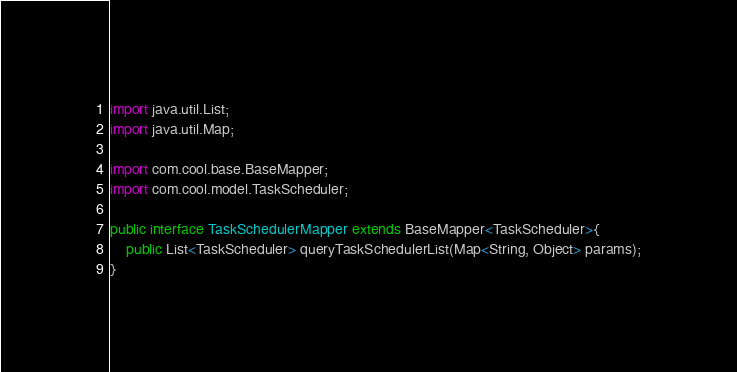Convert code to text. <code><loc_0><loc_0><loc_500><loc_500><_Java_>import java.util.List;
import java.util.Map;

import com.cool.base.BaseMapper;
import com.cool.model.TaskScheduler;

public interface TaskSchedulerMapper extends BaseMapper<TaskScheduler>{
	public List<TaskScheduler> queryTaskSchedulerList(Map<String, Object> params);
}
</code> 